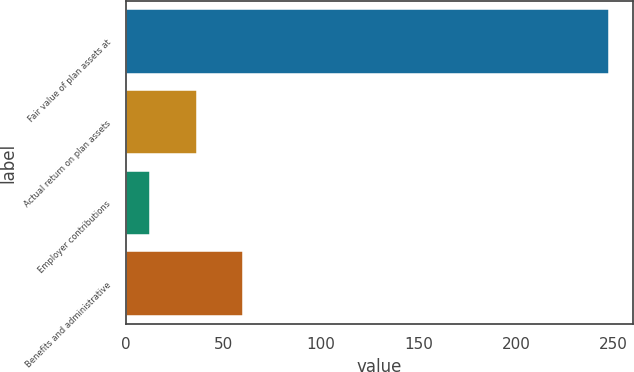Convert chart to OTSL. <chart><loc_0><loc_0><loc_500><loc_500><bar_chart><fcel>Fair value of plan assets at<fcel>Actual return on plan assets<fcel>Employer contributions<fcel>Benefits and administrative<nl><fcel>247.5<fcel>36.22<fcel>12.4<fcel>60.04<nl></chart> 